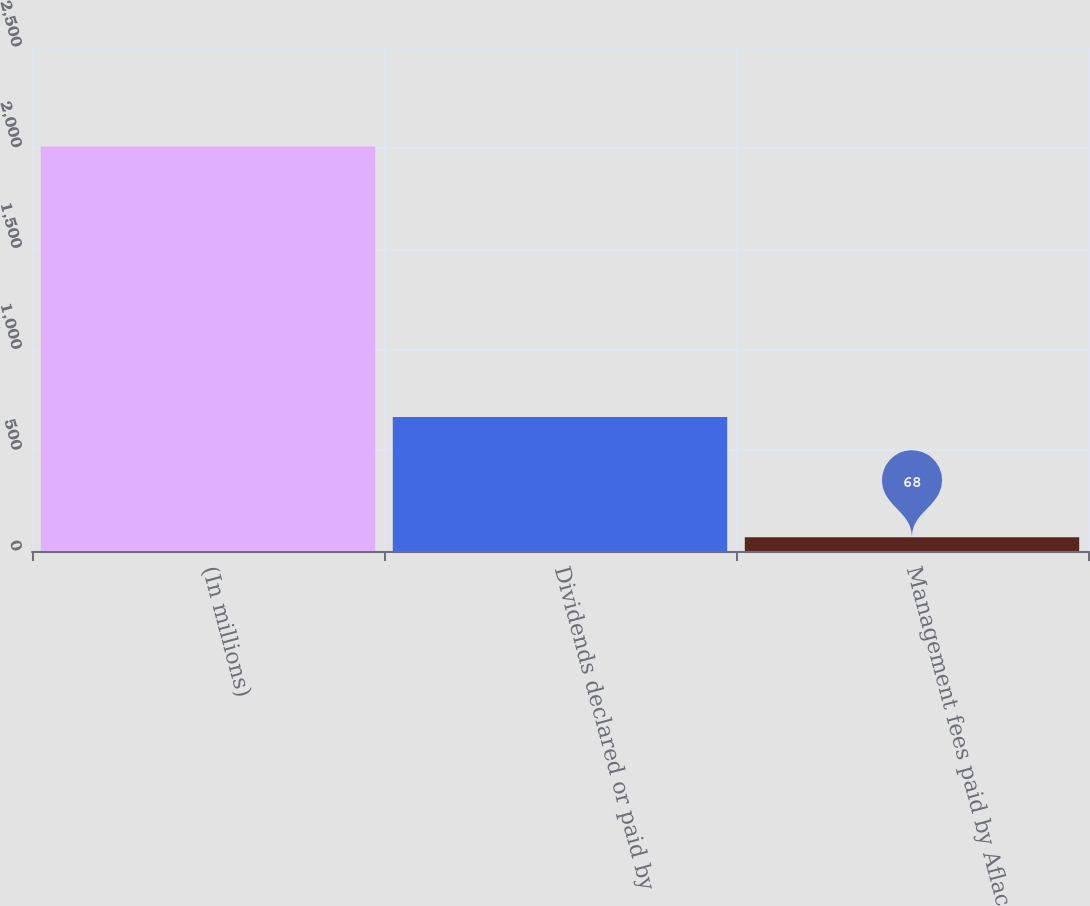Convert chart to OTSL. <chart><loc_0><loc_0><loc_500><loc_500><bar_chart><fcel>(In millions)<fcel>Dividends declared or paid by<fcel>Management fees paid by Aflac<nl><fcel>2006<fcel>665<fcel>68<nl></chart> 